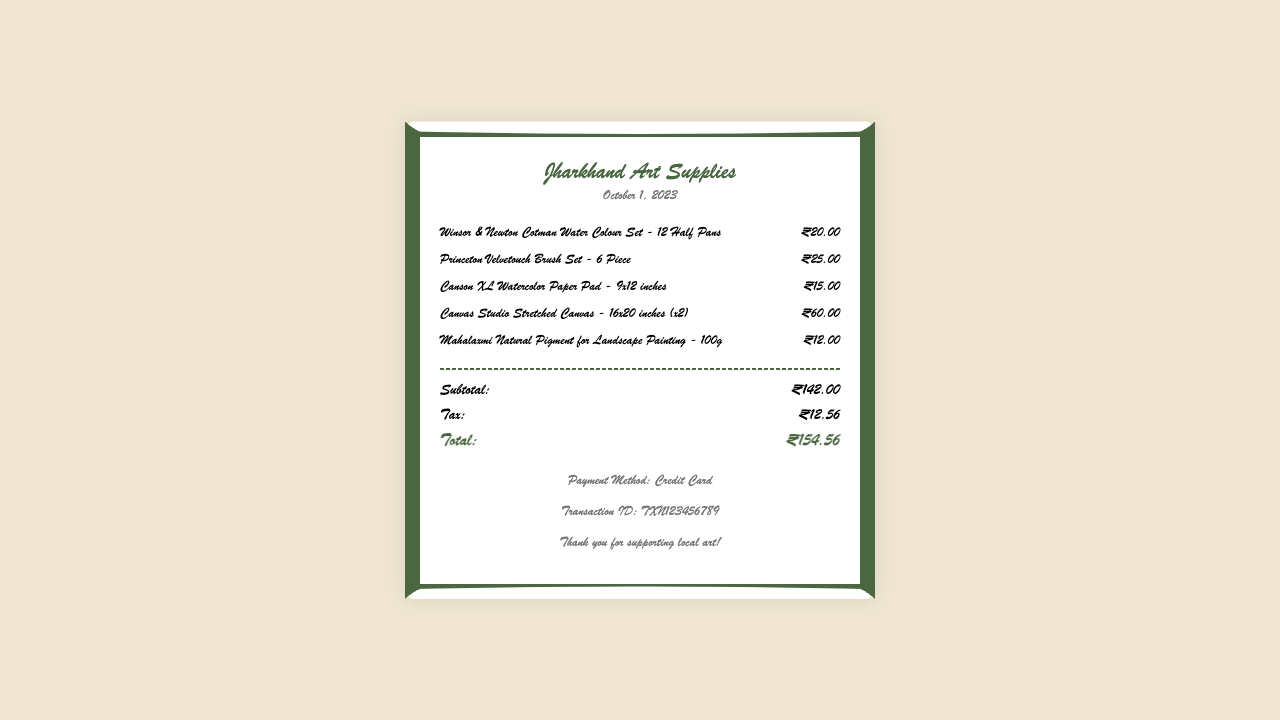What is the date of the purchase? The date is clearly mentioned in the document as the date of the transaction.
Answer: October 1, 2023 What is the name of the store? The store name is displayed prominently at the top of the receipt.
Answer: Jharkhand Art Supplies How much did the Winsor & Newton Cotman Water Colour Set cost? The price is specified next to the item description for each product on the receipt.
Answer: ₹20.00 What is the subtotal of the items purchased? The subtotal is calculated as the sum of all item prices listed before any taxes.
Answer: ₹142.00 What is the total amount spent? The total amount includes the subtotal plus tax, which is a final figure listed at the bottom of the receipt.
Answer: ₹154.56 How many pieces are in the Princeton Velvetouch Brush Set? The number of pieces is indicated in the item description next to the product on the receipt.
Answer: 6 Piece What payment method was used? The payment method is stated in the footer of the receipt, indicating how the payment was made.
Answer: Credit Card What is the tax amount charged? The tax amount is explicitly mentioned in the totals section of the receipt.
Answer: ₹12.56 How many Canvas Studio Stretched Canvases were purchased? The quantity is indicated in parentheses next to the item description for that product.
Answer: 2 